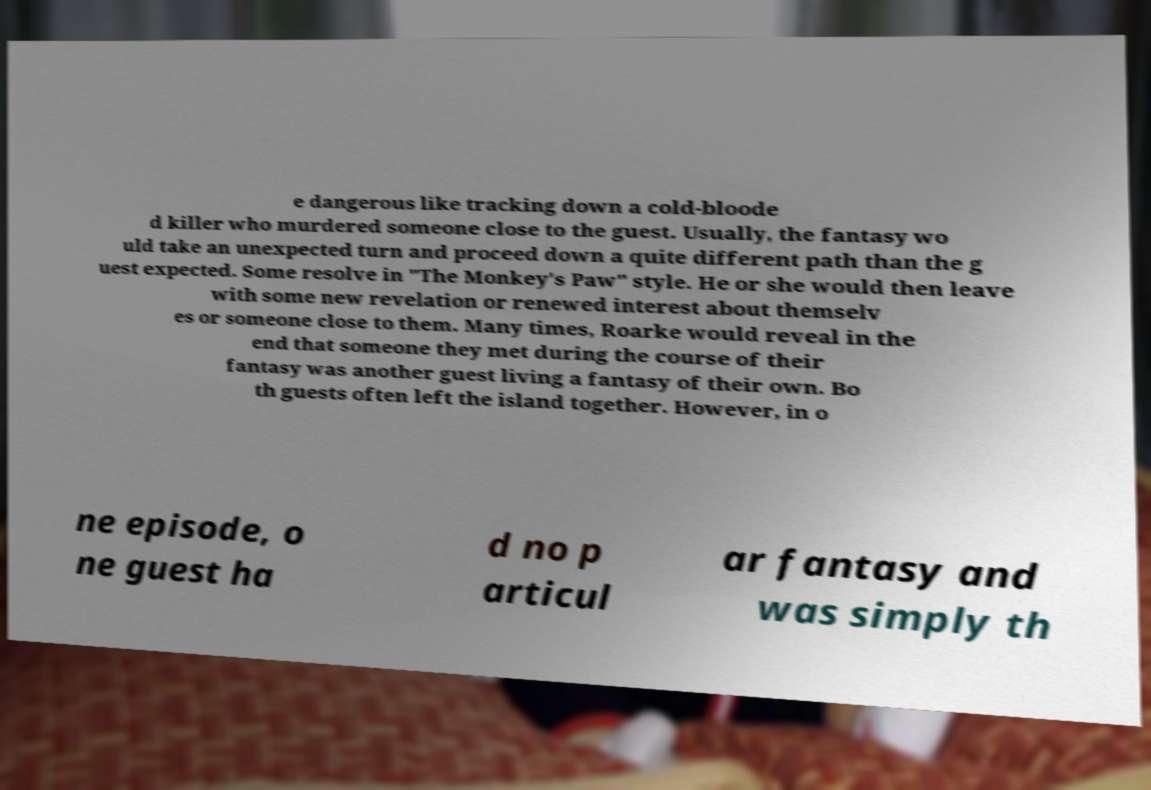For documentation purposes, I need the text within this image transcribed. Could you provide that? e dangerous like tracking down a cold-bloode d killer who murdered someone close to the guest. Usually, the fantasy wo uld take an unexpected turn and proceed down a quite different path than the g uest expected. Some resolve in "The Monkey's Paw" style. He or she would then leave with some new revelation or renewed interest about themselv es or someone close to them. Many times, Roarke would reveal in the end that someone they met during the course of their fantasy was another guest living a fantasy of their own. Bo th guests often left the island together. However, in o ne episode, o ne guest ha d no p articul ar fantasy and was simply th 